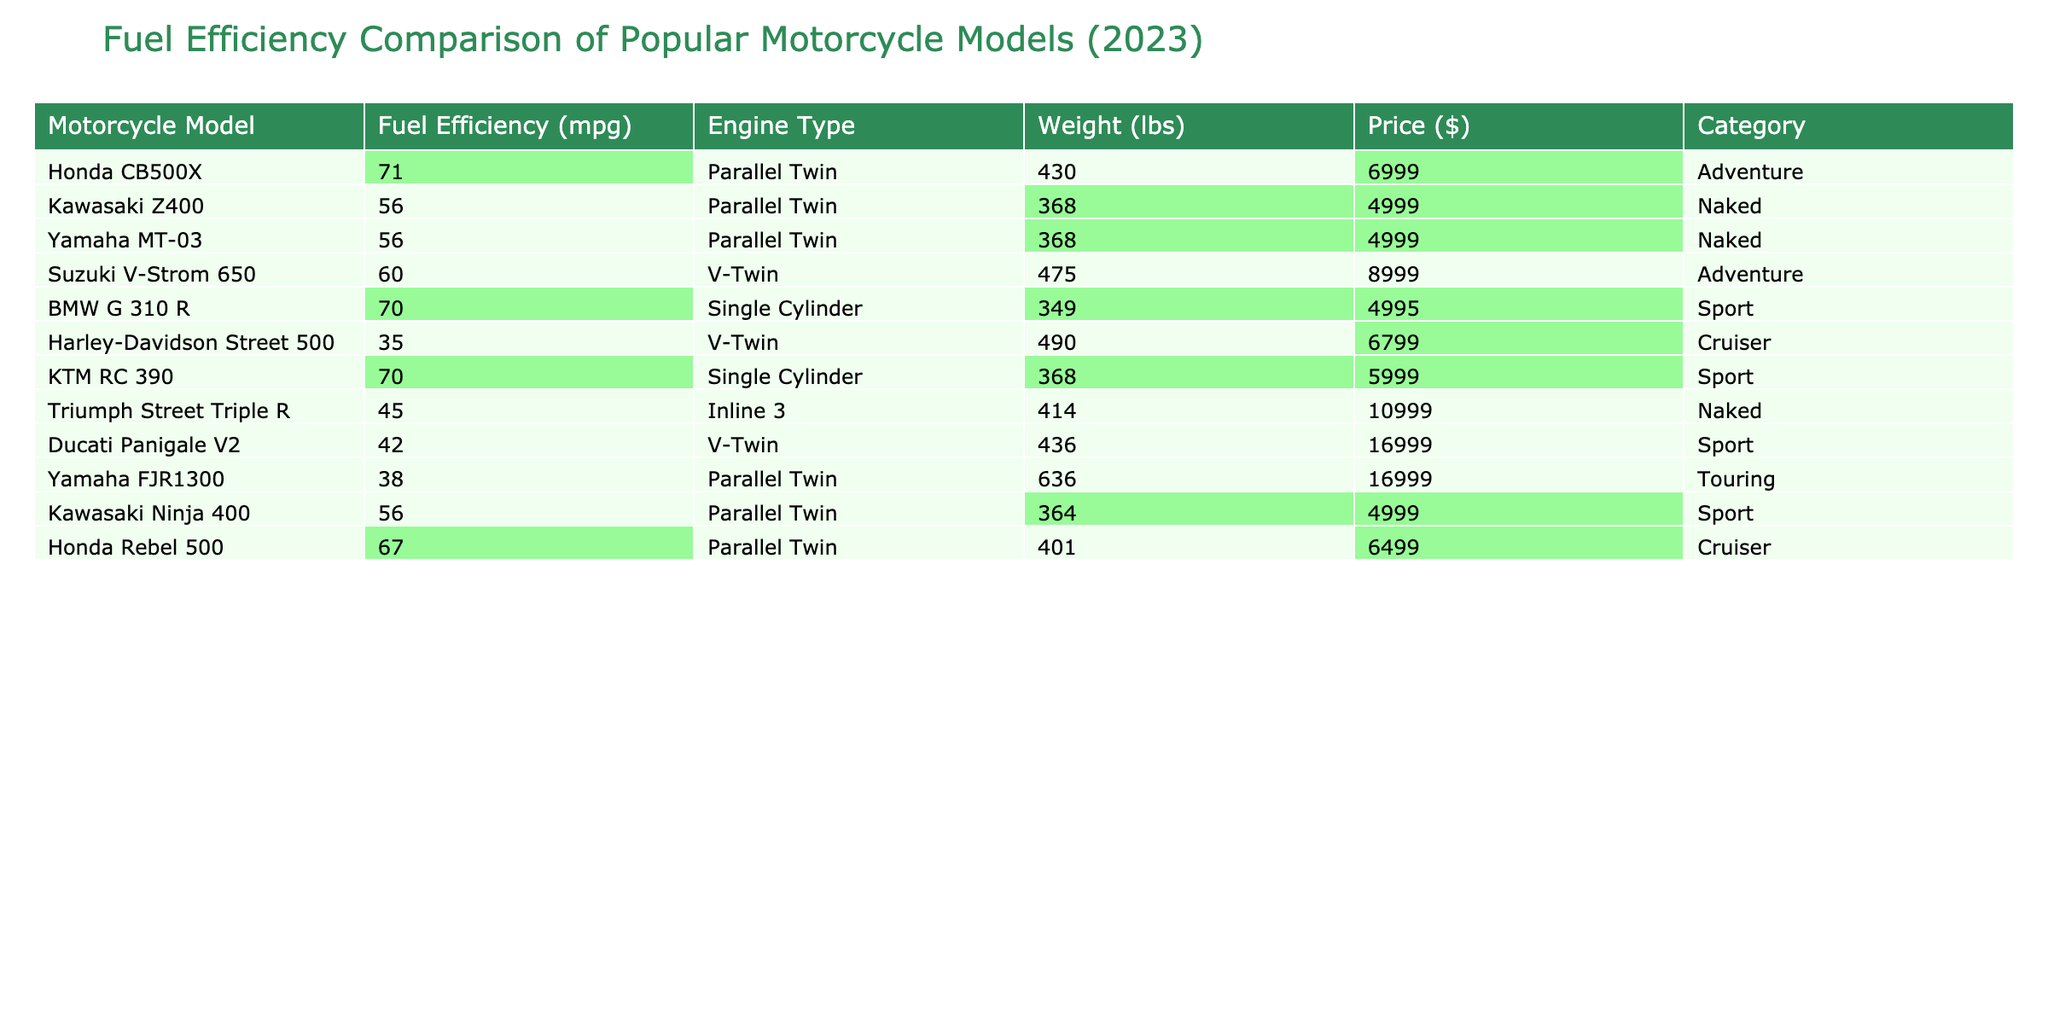What is the fuel efficiency of the Honda CB500X? The table shows that the fuel efficiency for the Honda CB500X is 71 mpg, which is directly listed in the "Fuel Efficiency (mpg)" column.
Answer: 71 mpg Which motorcycle model has the highest fuel efficiency? By examining the "Fuel Efficiency (mpg)" column, the Honda CB500X has the highest value of 71 mpg, which is greater than any other model listed.
Answer: Honda CB500X How many motorcycle models have a fuel efficiency greater than 60 mpg? Inspecting the "Fuel Efficiency (mpg)" column, the models that exceed 60 mpg are Honda CB500X, BMW G 310 R, KTM RC 390, and Honda Rebel 500, making a total of 4 models.
Answer: 4 What is the price of the most expensive motorcycle model in the table? Looking at the "Price ($)" column, the Ducati Panigale V2 has the highest price at $16,999.
Answer: $16,999 Is the weight of the Yamaha FJR1300 below 700 lbs? The weight of the Yamaha FJR1300 is 636 lbs, which is below the 700 lbs threshold stated in the question.
Answer: Yes What is the average fuel efficiency of the motorcycle models in the sport category? The fuel efficiencies for the sport category are 70 (KTM RC 390), 42 (Ducati Panigale V2), 56 (Kawasaki Ninja 400). The average is calculated as (70 + 42 + 56) / 3 = 56.
Answer: 56 mpg Which motorcycle models weigh less than 400 lbs and what are their fuel efficiencies? Inspecting the "Weight (lbs)" column, the BMW G 310 R (349 lbs) and Kawasaki Z400 (368 lbs) weigh less than 400 lbs. Their fuel efficiencies are 70 mpg and 56 mpg, respectively.
Answer: BMW G 310 R: 70 mpg, Kawasaki Z400: 56 mpg How much heavier is the Harley-Davidson Street 500 compared to the BMW G 310 R? The weight of the Harley-Davidson Street 500 is 490 lbs, and the weight of the BMW G 310 R is 349 lbs. The difference is 490 - 349 = 141 lbs.
Answer: 141 lbs What percentage of motorcycle models on the list fall into the cruiser category? There are 2 cruiser models (Harley-Davidson Street 500 and Honda Rebel 500) out of a total of 12 models. The percentage is (2/12) * 100 = 16.67%.
Answer: 16.67% Which model has the best fuel efficiency while also being priced below $7,000? The Honda Rebel 500 offers a fuel efficiency of 67 mpg and is priced at $6,499, making it the best fuel-efficient model under $7,000.
Answer: Honda Rebel 500 What are the fuel efficiencies of motorcycles that are both adventure models and priced above $8,000? The only adventure model priced above $8,000 is the Suzuki V-Strom 650, which has a fuel efficiency of 60 mpg.
Answer: 60 mpg 